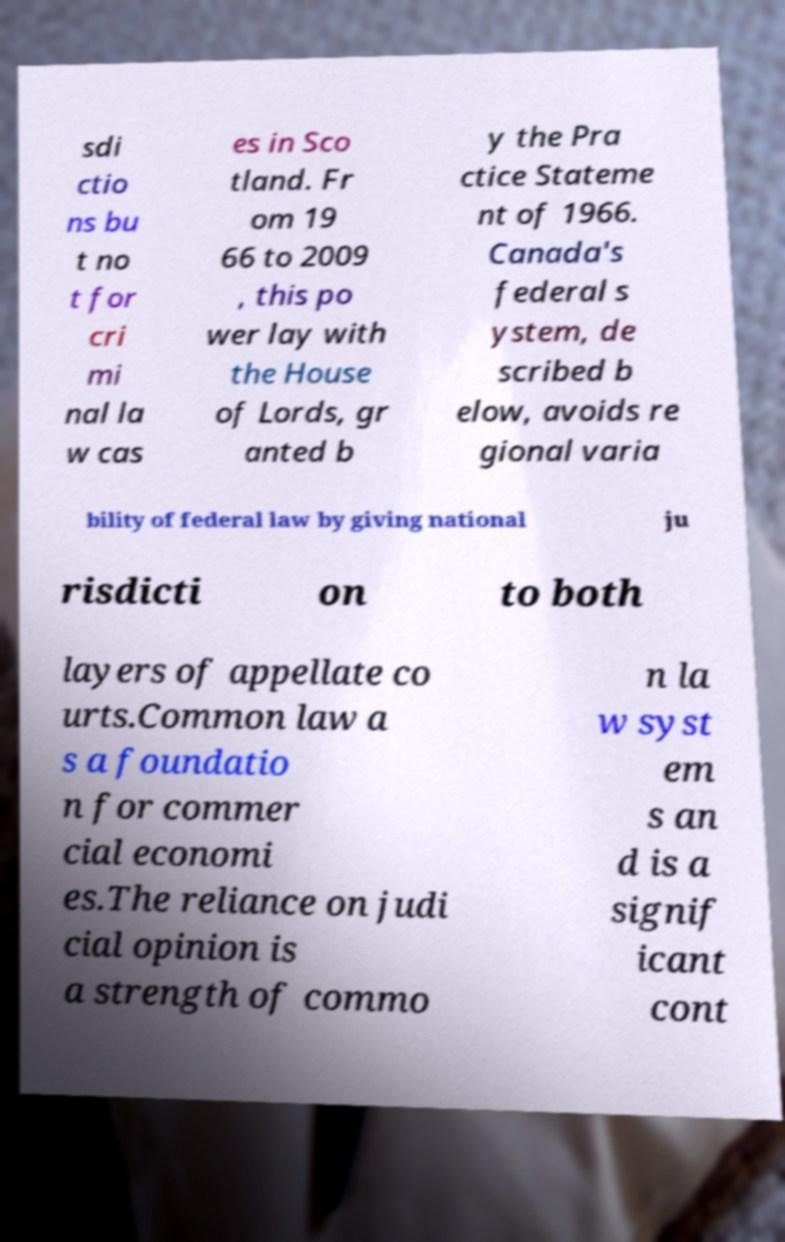Can you read and provide the text displayed in the image?This photo seems to have some interesting text. Can you extract and type it out for me? sdi ctio ns bu t no t for cri mi nal la w cas es in Sco tland. Fr om 19 66 to 2009 , this po wer lay with the House of Lords, gr anted b y the Pra ctice Stateme nt of 1966. Canada's federal s ystem, de scribed b elow, avoids re gional varia bility of federal law by giving national ju risdicti on to both layers of appellate co urts.Common law a s a foundatio n for commer cial economi es.The reliance on judi cial opinion is a strength of commo n la w syst em s an d is a signif icant cont 